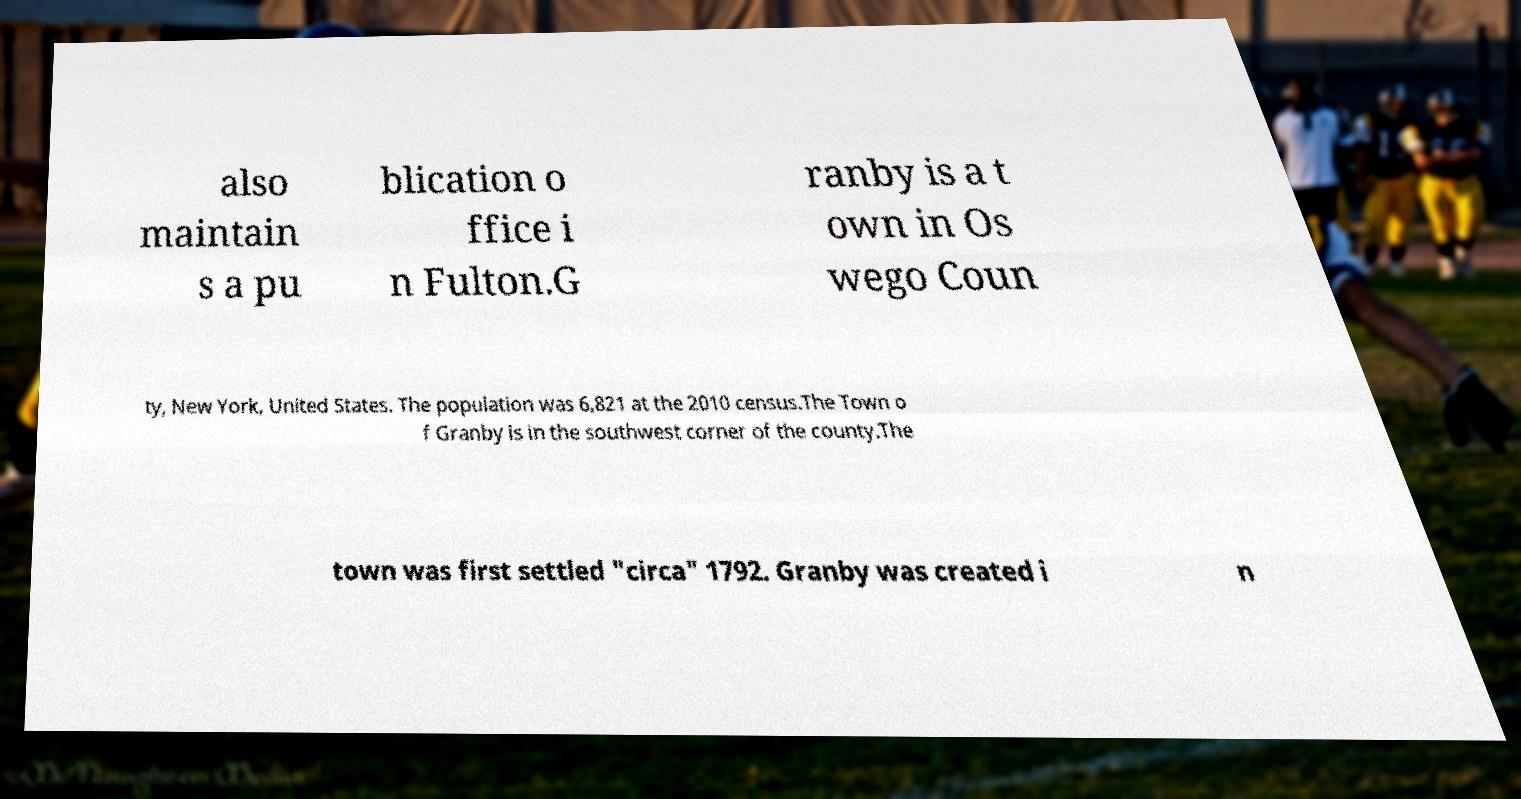For documentation purposes, I need the text within this image transcribed. Could you provide that? also maintain s a pu blication o ffice i n Fulton.G ranby is a t own in Os wego Coun ty, New York, United States. The population was 6,821 at the 2010 census.The Town o f Granby is in the southwest corner of the county.The town was first settled "circa" 1792. Granby was created i n 